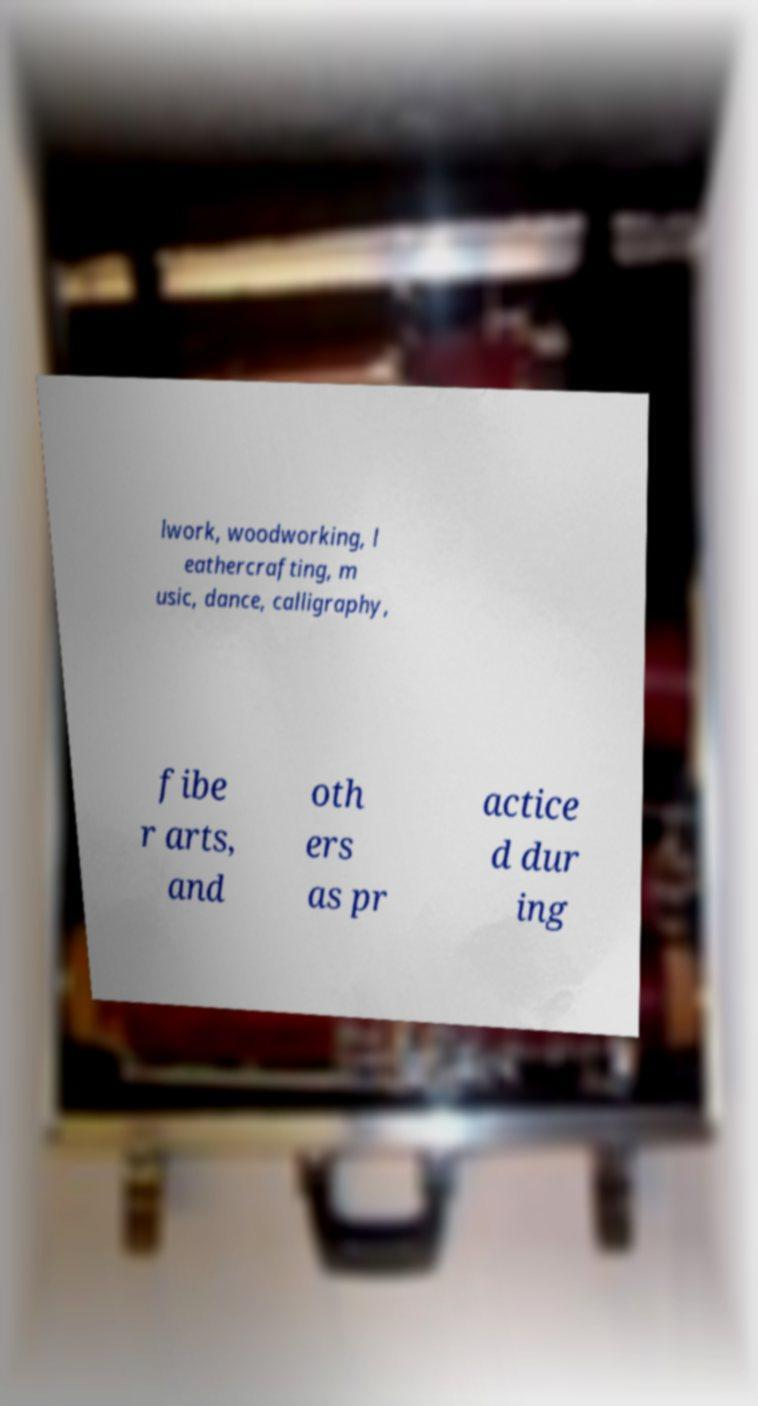What messages or text are displayed in this image? I need them in a readable, typed format. lwork, woodworking, l eathercrafting, m usic, dance, calligraphy, fibe r arts, and oth ers as pr actice d dur ing 